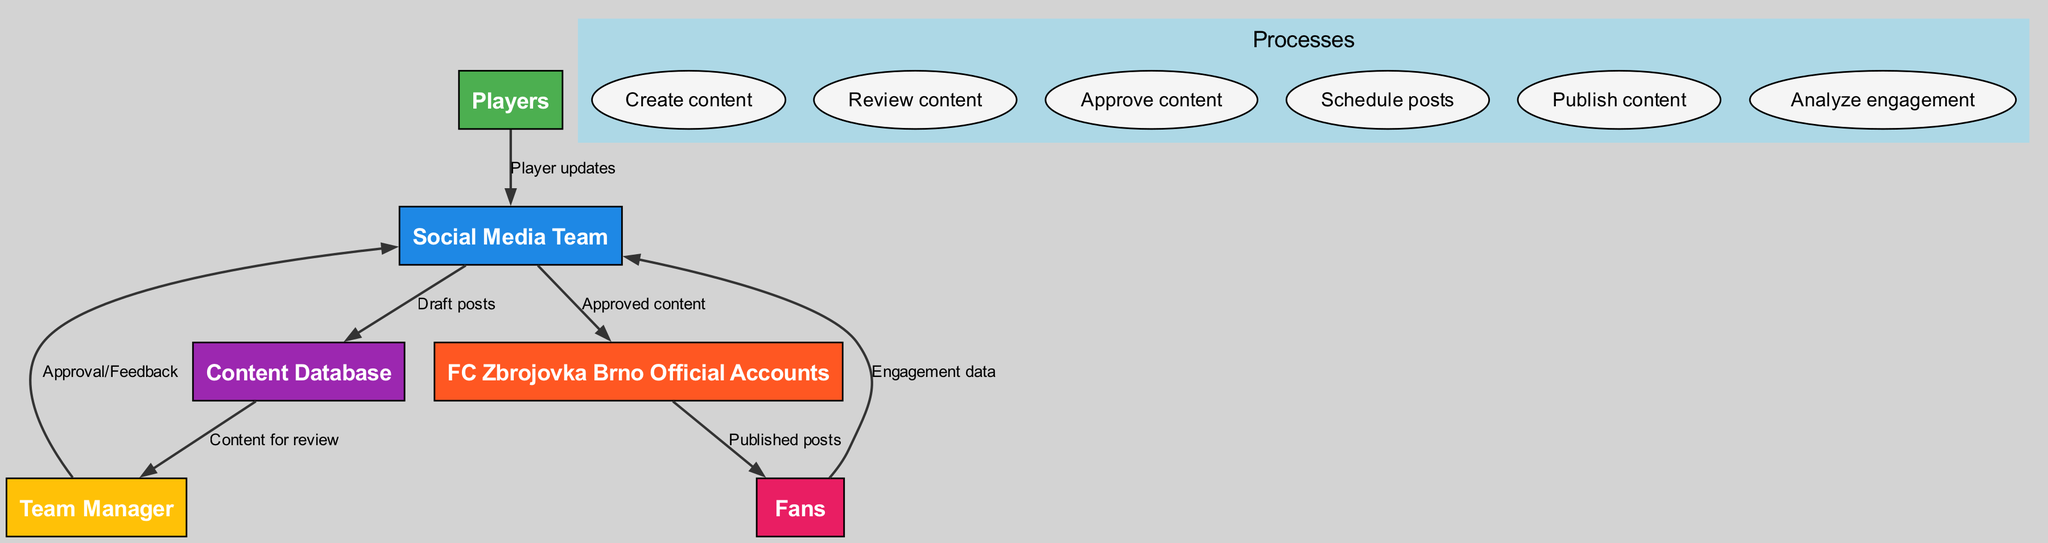What are the entities involved in the social media workflow? The diagram lists several entities, including Social Media Team, Team Manager, Players, Fans, Content Database, and FC Zbrojovka Brno Official Accounts.
Answer: Social Media Team, Team Manager, Players, Fans, Content Database, FC Zbrojovka Brno Official Accounts Who creates the content? According to the data flow, the Social Media Team is responsible for creating content based on updates from Players.
Answer: Social Media Team Which entity receives the engagement data? The Fans send engagement data back to the Social Media Team after the published posts.
Answer: Social Media Team What is the label of the flow from the Content Database to the Team Manager? The label of the flow from the Content Database to the Team Manager is "Content for review".
Answer: Content for review How many processes are defined in the diagram? There are six processes listed within the diagram including Create content, Review content, Approve content, Schedule posts, Publish content, and Analyze engagement.
Answer: Six What happens after the Team Manager gives approval or feedback? After receiving approval or feedback from the Team Manager, the Social Media Team will send the approved content to the FC Zbrojovka Brno Official Accounts for scheduling and publishing.
Answer: The approved content is sent to the FC Zbrojovka Brno Official Accounts What is the final output of the workflow? The workflow culminates in the Fans receiving published posts from the FC Zbrojovka Brno Official Accounts.
Answer: Published posts From where does the Social Media Team receive player updates? The Social Media Team receives player updates directly from the Players.
Answer: Players 